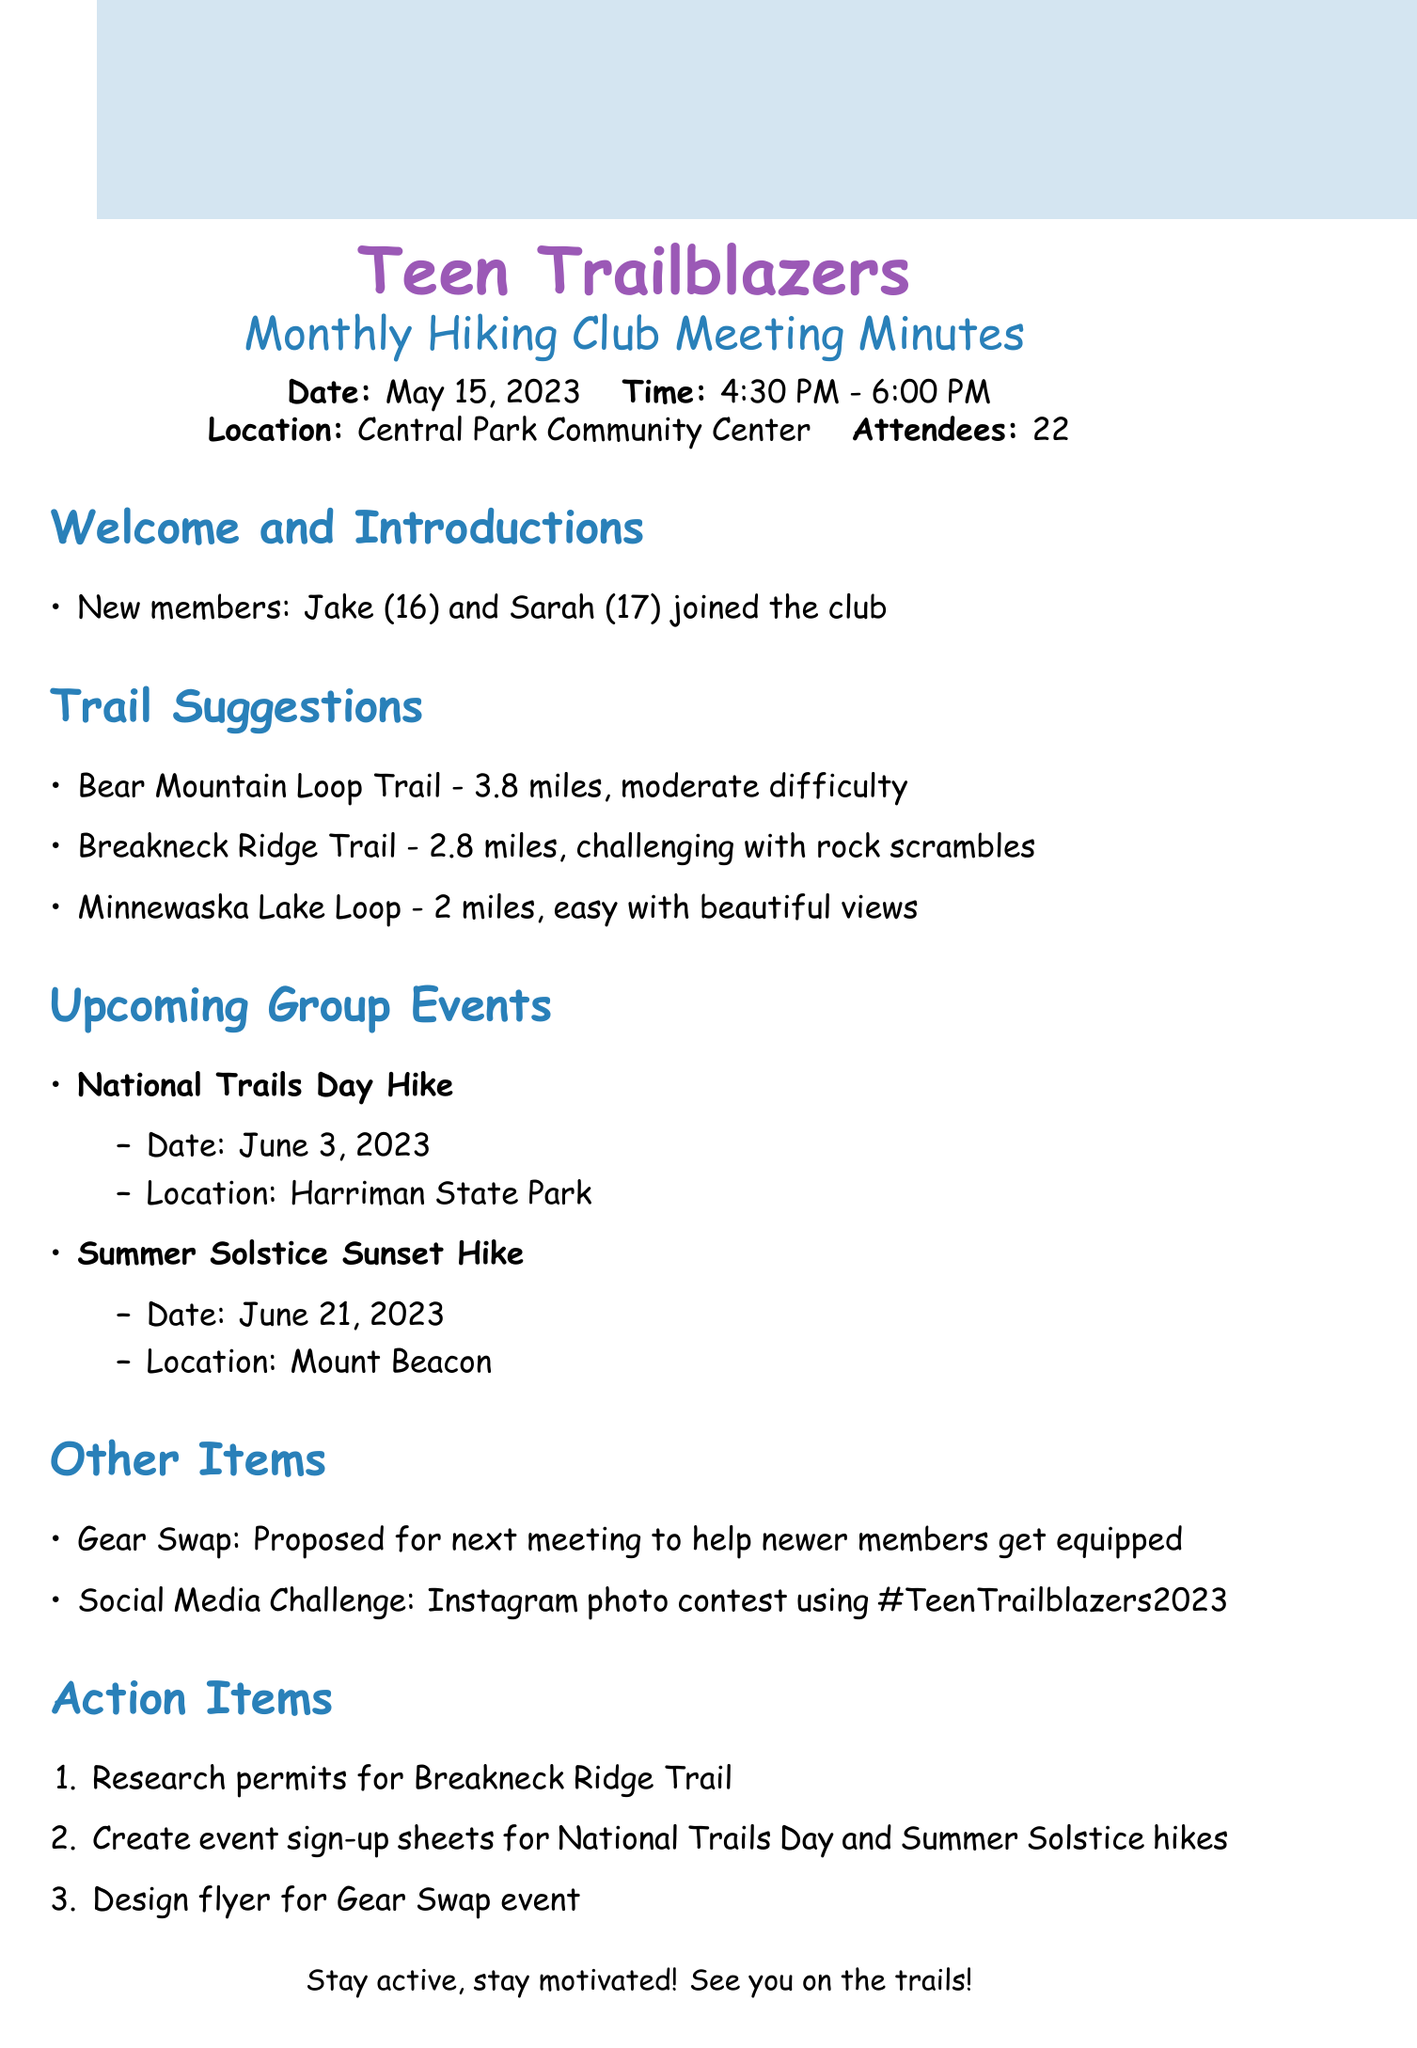What date was the meeting held? The date of the meeting is stated at the beginning of the document.
Answer: May 15, 2023 Who are the new members that joined the club? The names of the new members are listed in the "Welcome and Introductions" section.
Answer: Jake and Sarah What is the length of the Breakneck Ridge Trail? The length of the Breakneck Ridge Trail is mentioned in the "Trail Suggestions" section.
Answer: 2.8 miles When is the Summer Solstice Sunset Hike scheduled? The date for the Summer Solstice Sunset Hike is provided in the "Upcoming Group Events" section.
Answer: June 21, 2023 What event is proposed for the next meeting? This event is listed in the "Other Items" section regarding helping new members.
Answer: Gear Swap How many attendees were present at the meeting? The total number of attendees is noted at the beginning of the document.
Answer: 22 Which trail is described as easy with beautiful views? The description for this trail is provided in the "Trail Suggestions" section.
Answer: Minnewaska Lake Loop What hashtag is used for the social media challenge? The hashtag for the Instagram photo contest is specified in the "Social Media Challenge" section.
Answer: #TeenTrailblazers2023 